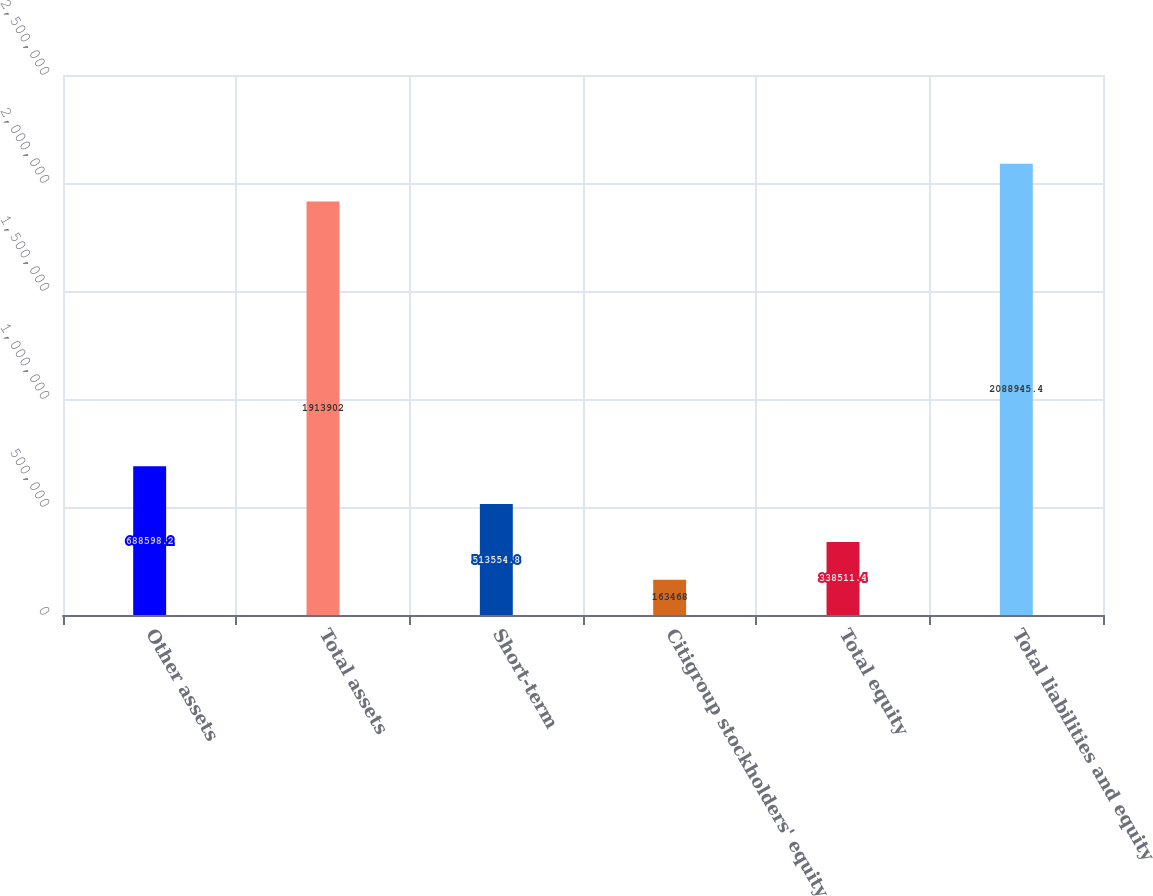<chart> <loc_0><loc_0><loc_500><loc_500><bar_chart><fcel>Other assets<fcel>Total assets<fcel>Short-term<fcel>Citigroup stockholders' equity<fcel>Total equity<fcel>Total liabilities and equity<nl><fcel>688598<fcel>1.9139e+06<fcel>513555<fcel>163468<fcel>338511<fcel>2.08895e+06<nl></chart> 